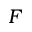<formula> <loc_0><loc_0><loc_500><loc_500>F</formula> 